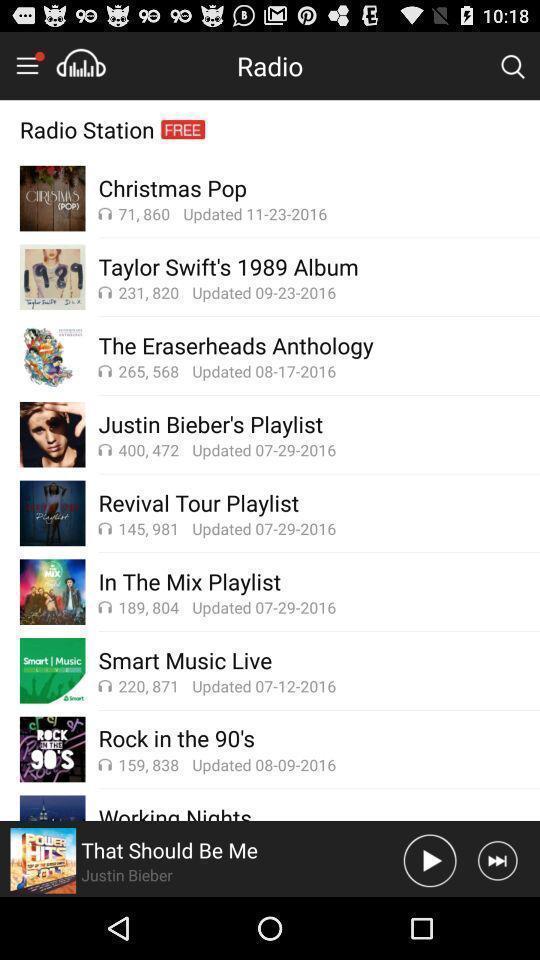What is the overall content of this screenshot? Screen showing multiple playlists in a music player app. 